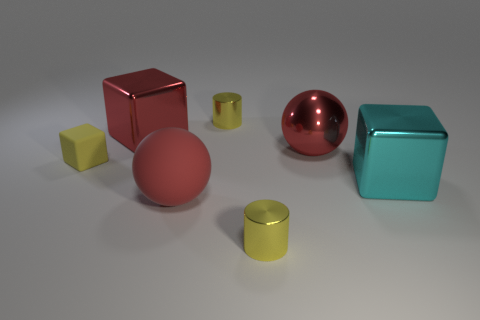There is a tiny yellow object that is the same shape as the big cyan metallic object; what is it made of?
Provide a short and direct response. Rubber. There is a block that is both on the right side of the tiny rubber cube and in front of the big red metal cube; how big is it?
Provide a short and direct response. Large. What is the material of the other sphere that is the same size as the red metallic sphere?
Ensure brevity in your answer.  Rubber. There is a red matte sphere that is in front of the tiny shiny cylinder behind the large rubber ball; how many tiny metallic cylinders are behind it?
Your answer should be compact. 1. There is a rubber cube that is to the left of the large red block; is its color the same as the cylinder that is behind the large rubber ball?
Provide a short and direct response. Yes. There is a tiny object that is both right of the red rubber object and behind the cyan cube; what is its color?
Provide a succinct answer. Yellow. What number of cyan cubes have the same size as the red rubber sphere?
Keep it short and to the point. 1. There is a small yellow shiny object left of the tiny metallic cylinder in front of the cyan thing; what shape is it?
Keep it short and to the point. Cylinder. What is the shape of the large red metal object that is left of the shiny object that is in front of the rubber object that is right of the red cube?
Give a very brief answer. Cube. What number of other large metal things are the same shape as the cyan shiny object?
Keep it short and to the point. 1. 